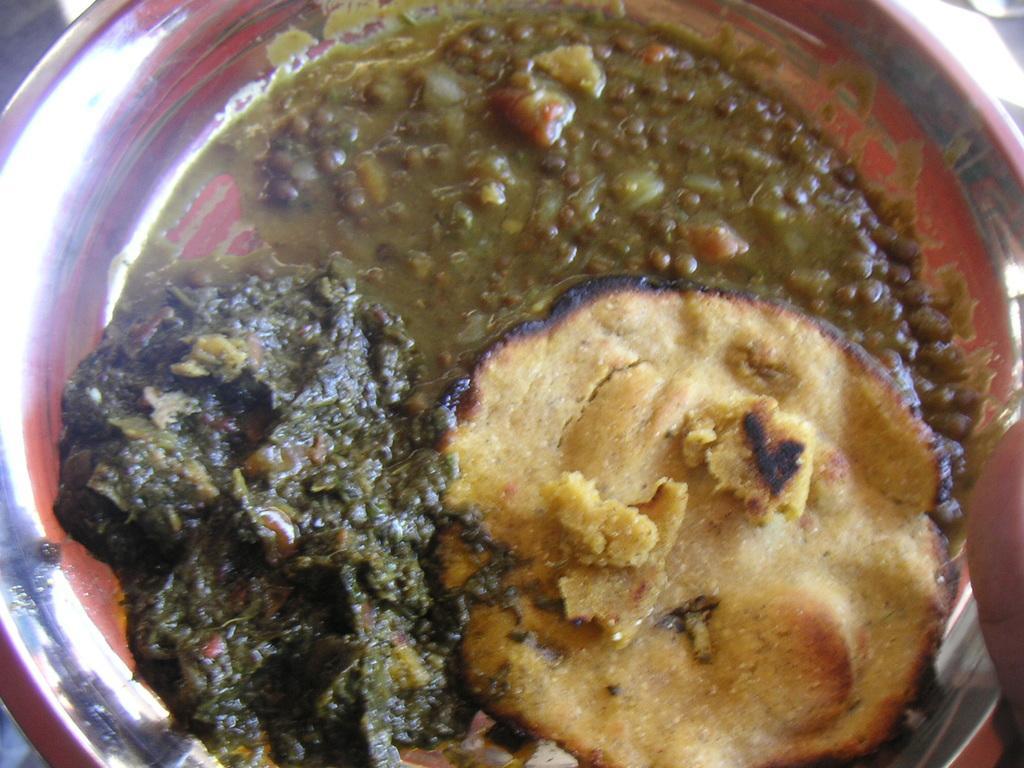Describe this image in one or two sentences. In this image I can see a bowl and in the bowl I can see a food item which is brown , green and orange in color. 